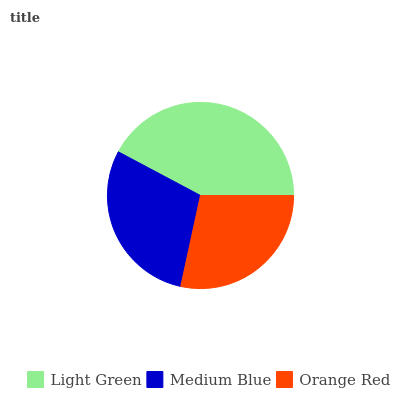Is Orange Red the minimum?
Answer yes or no. Yes. Is Light Green the maximum?
Answer yes or no. Yes. Is Medium Blue the minimum?
Answer yes or no. No. Is Medium Blue the maximum?
Answer yes or no. No. Is Light Green greater than Medium Blue?
Answer yes or no. Yes. Is Medium Blue less than Light Green?
Answer yes or no. Yes. Is Medium Blue greater than Light Green?
Answer yes or no. No. Is Light Green less than Medium Blue?
Answer yes or no. No. Is Medium Blue the high median?
Answer yes or no. Yes. Is Medium Blue the low median?
Answer yes or no. Yes. Is Orange Red the high median?
Answer yes or no. No. Is Orange Red the low median?
Answer yes or no. No. 